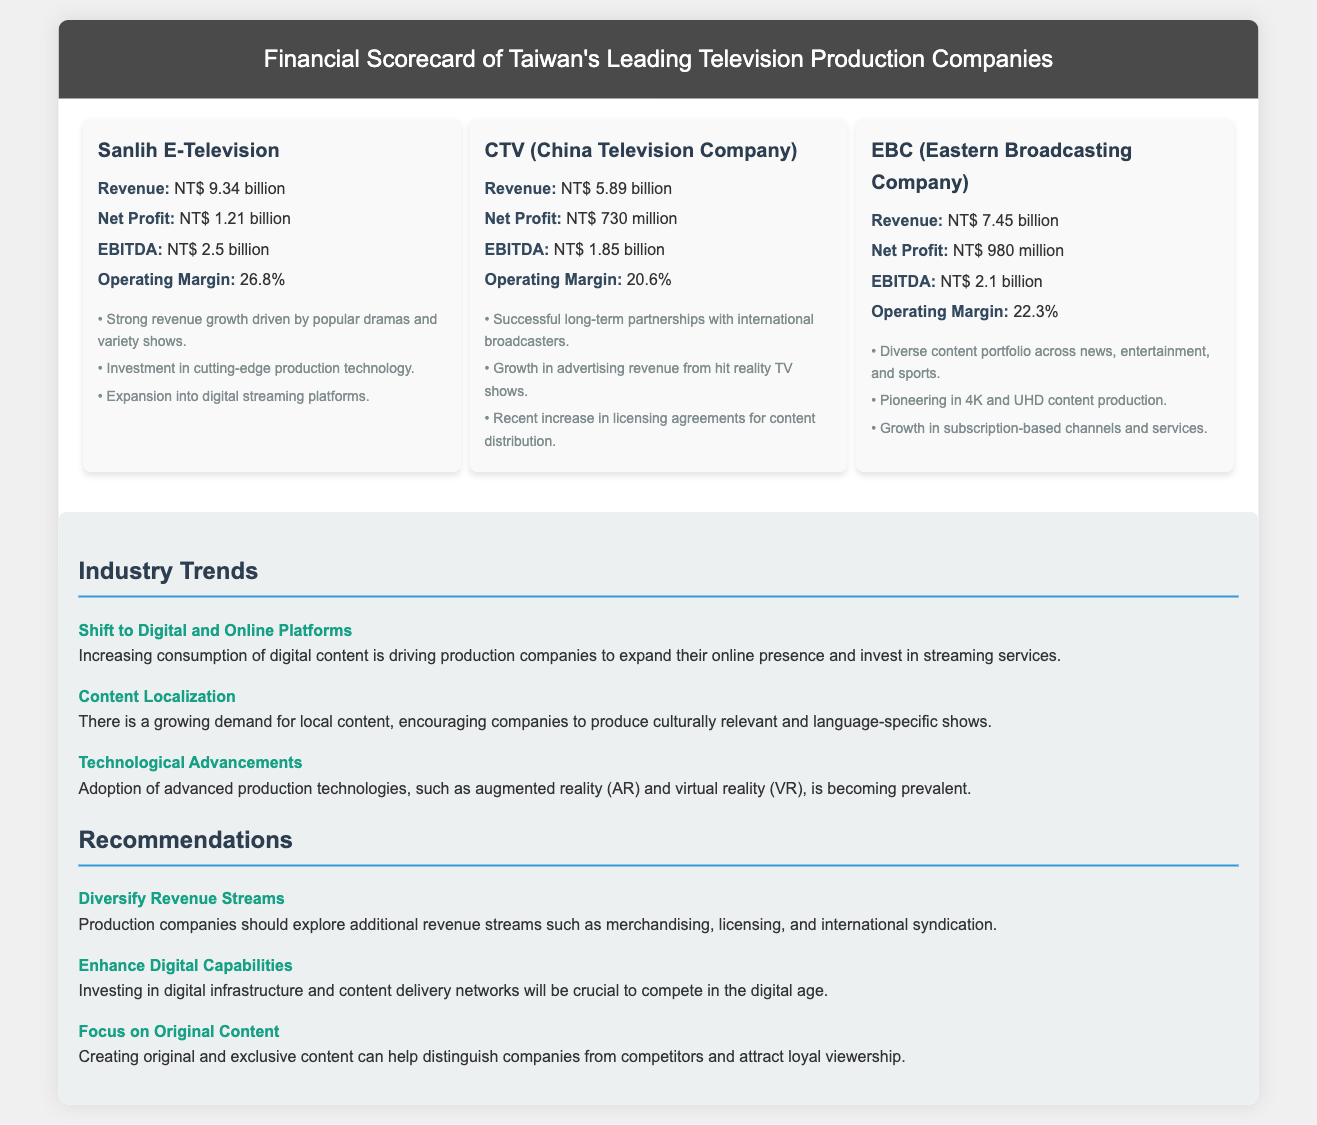What is the revenue of Sanlih E-Television? The revenue for Sanlih E-Television is explicitly stated in the document.
Answer: NT$ 9.34 billion What is the net profit of CTV? The net profit of CTV is provided in the respective section of the document.
Answer: NT$ 730 million What is EBC's operating margin? The operating margin for EBC can be found in the performance metrics listed.
Answer: 22.3% Which company has the highest EBITDA? Comparing the EBITDA values from all companies mentioned helps determine which has the highest.
Answer: Sanlih E-Television What trend is related to content localization? The specific trend mentioned in the document refers to content that is culturally relevant and language-specific.
Answer: Content Localization What is one highlight of EBC's performance? Highlights listed for EBC include its accomplishments and innovative practices, found in the document.
Answer: Pioneering in 4K and UHD content production What is a recommendation for production companies? Recommendations provided focus on areas for improvement and business strategy adjustments outlined in the document.
Answer: Diversify Revenue Streams What is one technological advancement trend mentioned? The document outlines technological advancements being adopted by production companies, needing a detailed comparison.
Answer: Technological Advancements How many companies are featured in this scorecard? The document lists individual companies, which allows for easy counting of entries provided in the scorecard.
Answer: Three 